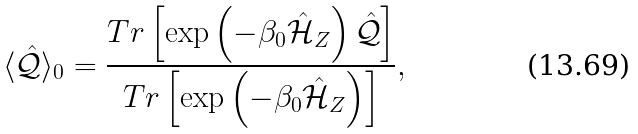Convert formula to latex. <formula><loc_0><loc_0><loc_500><loc_500>\langle \mathcal { \hat { Q } } \rangle _ { 0 } = \frac { T r \left [ \exp \left ( - \beta _ { 0 } \mathcal { \hat { H } } _ { Z } \right ) \mathcal { \hat { Q } } \right ] } { T r \left [ \exp \left ( - \beta _ { 0 } \mathcal { \hat { H } } _ { Z } \right ) \right ] } ,</formula> 